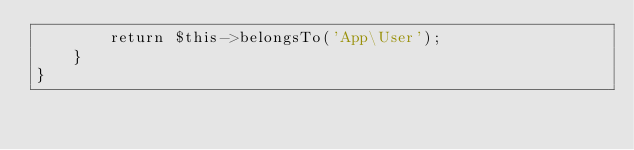<code> <loc_0><loc_0><loc_500><loc_500><_PHP_>        return $this->belongsTo('App\User');
    }
}
</code> 